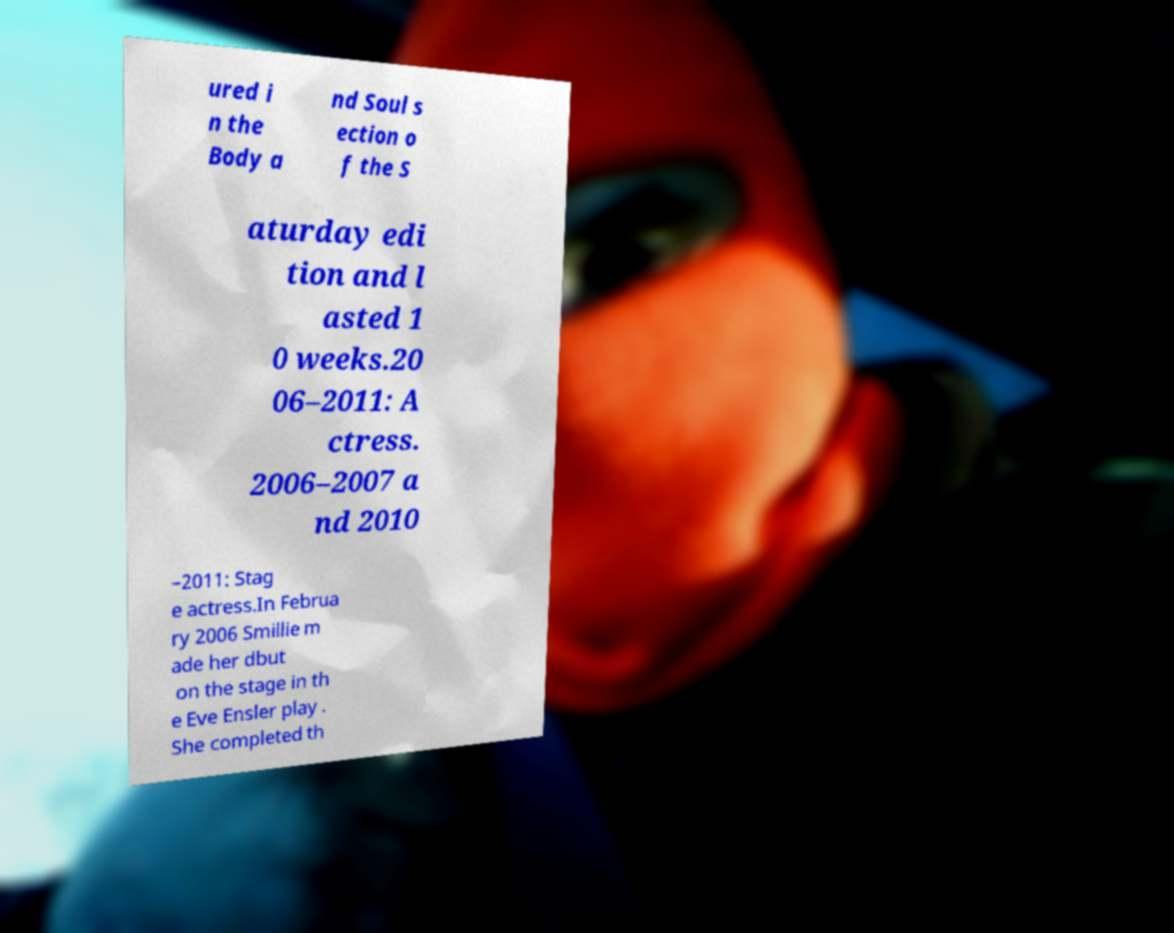There's text embedded in this image that I need extracted. Can you transcribe it verbatim? ured i n the Body a nd Soul s ection o f the S aturday edi tion and l asted 1 0 weeks.20 06–2011: A ctress. 2006–2007 a nd 2010 –2011: Stag e actress.In Februa ry 2006 Smillie m ade her dbut on the stage in th e Eve Ensler play . She completed th 